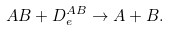<formula> <loc_0><loc_0><loc_500><loc_500>A B + D _ { e } ^ { A B } \rightarrow A + B .</formula> 